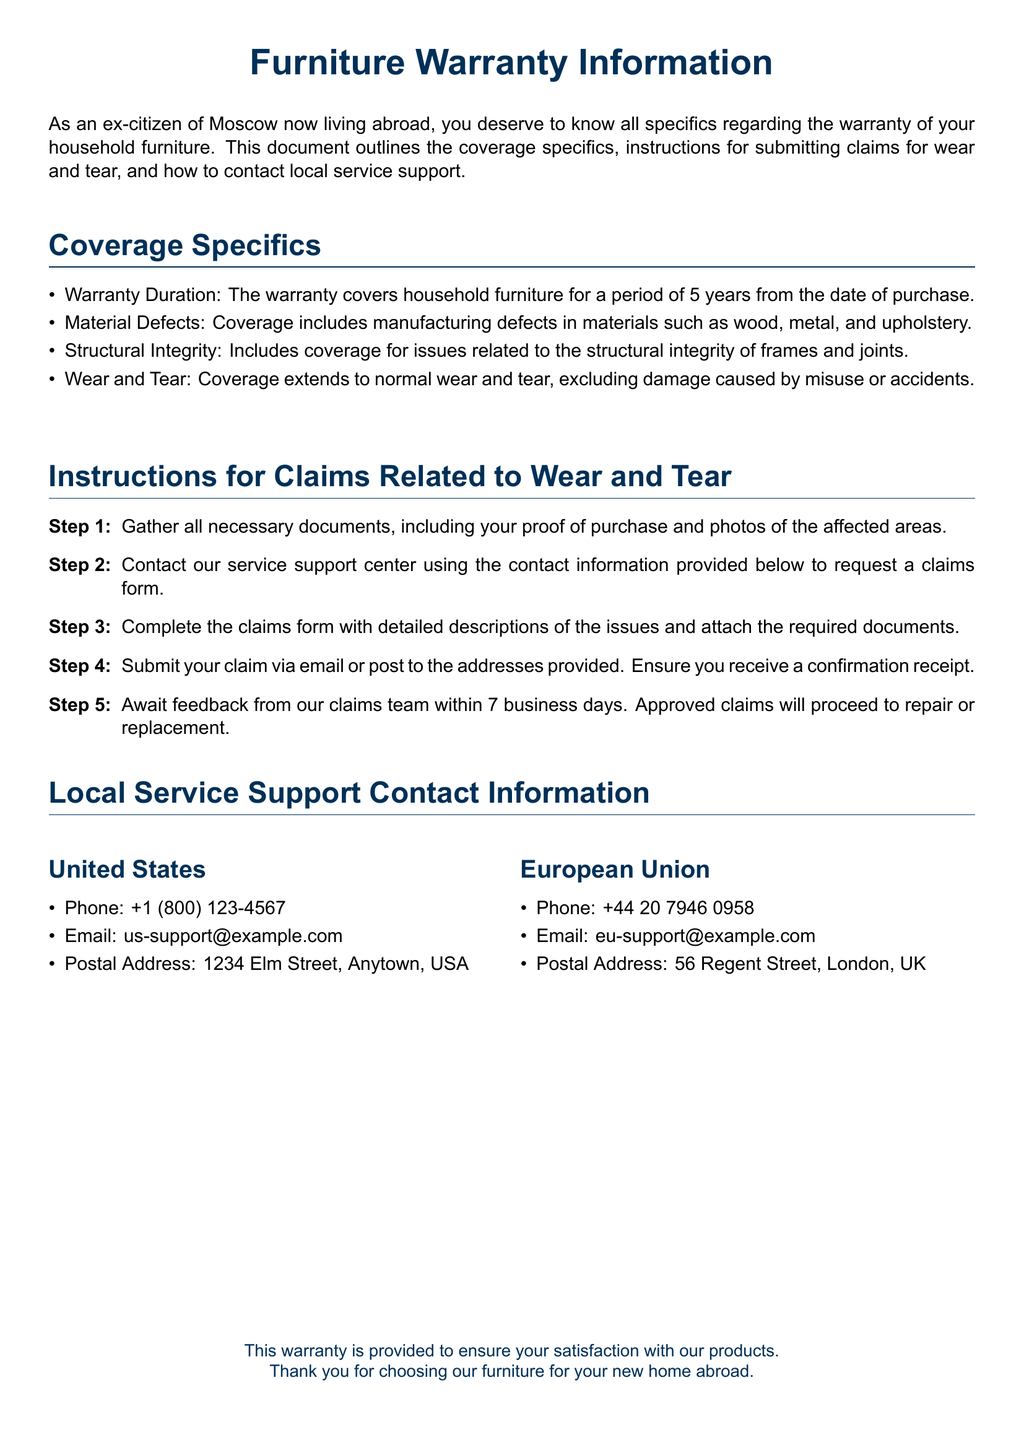What is the warranty duration for household furniture? The warranty duration is outlined in the coverage specifics section.
Answer: 5 years What types of defects are covered under the warranty? The document specifies the types of defects covered within the coverage specifics.
Answer: Manufacturing defects How many steps are listed for submitting a claim? The instructions for claims related to wear and tear provide a numbered list of steps.
Answer: 5 steps What should you gather first when submitting a claim? The first step in the claims process indicates what documents are needed.
Answer: Necessary documents How long will it take to receive feedback on a claim? The document mentions the timeframe for feedback from the claims team in the instructions.
Answer: 7 business days What is the phone number for service support in the United States? The contact information section provides specific phone numbers for each region.
Answer: +1 (800) 123-4567 What type of damage is excluded from the warranty coverage? The coverage specifics section details what is not covered under normal wear and tear.
Answer: Misuse or accidents Which email address should you use for support in the European Union? The local service support contact information includes an email for the EU.
Answer: eu-support@example.com 